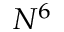<formula> <loc_0><loc_0><loc_500><loc_500>N ^ { 6 }</formula> 